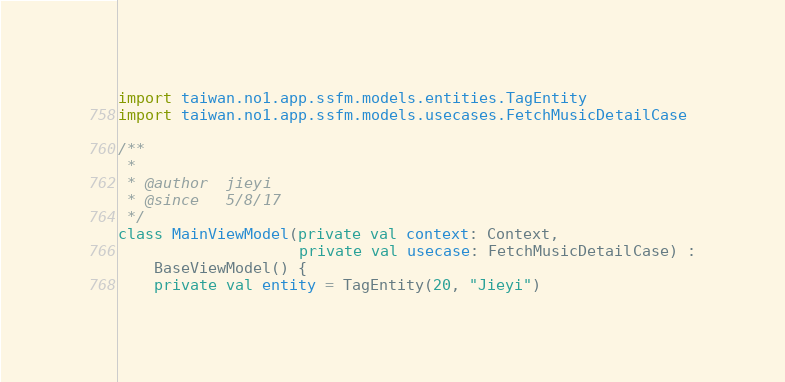Convert code to text. <code><loc_0><loc_0><loc_500><loc_500><_Kotlin_>import taiwan.no1.app.ssfm.models.entities.TagEntity
import taiwan.no1.app.ssfm.models.usecases.FetchMusicDetailCase

/**
 *
 * @author  jieyi
 * @since   5/8/17
 */
class MainViewModel(private val context: Context,
                    private val usecase: FetchMusicDetailCase) :
    BaseViewModel() {
    private val entity = TagEntity(20, "Jieyi")
</code> 